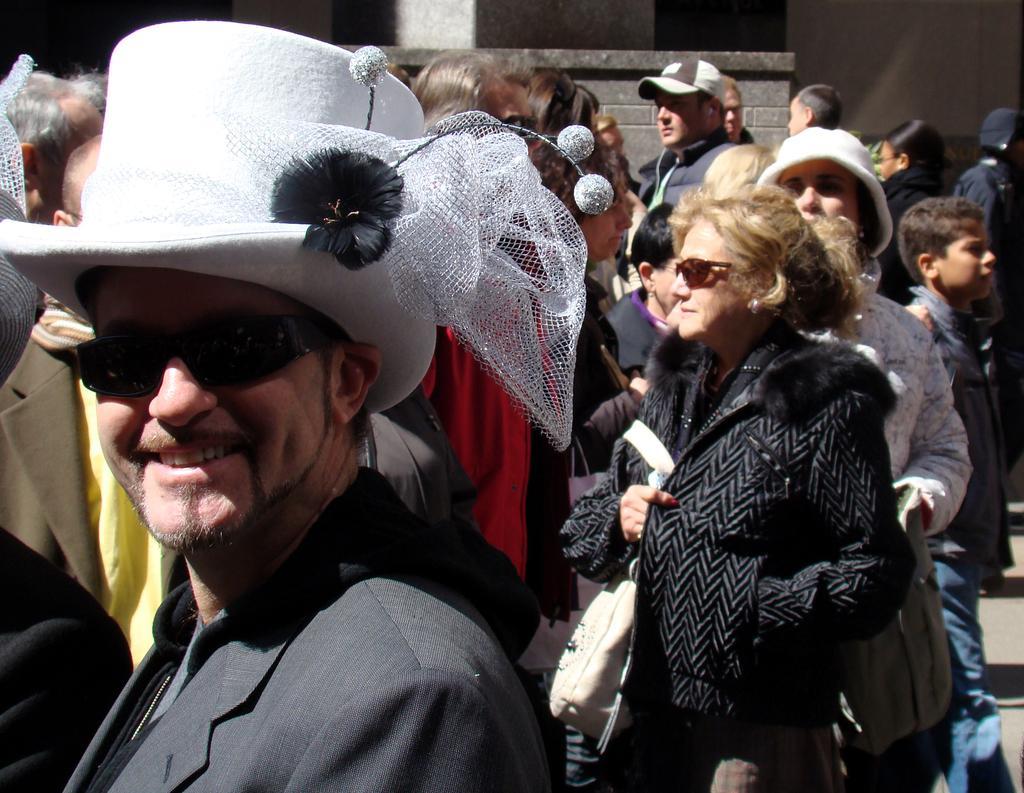Describe this image in one or two sentences. In the foreground of the image there is a person wearing a suit and a white color hat. In the background of the image there are people. There is a wall. 